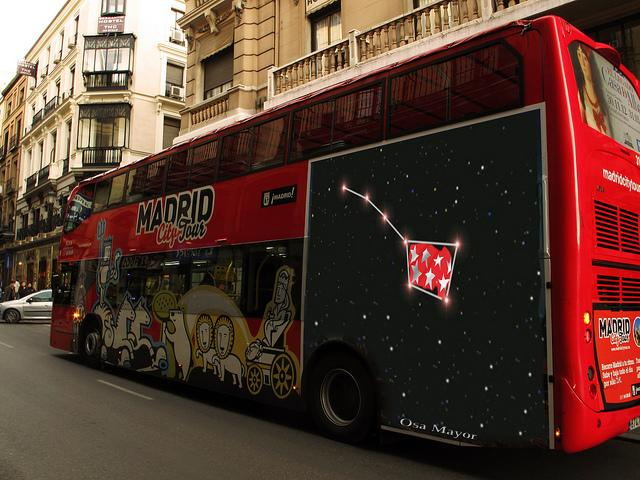What is this constellation often called in English?

Choices:
A) orion
B) big dipper
C) pisces
D) virgo big dipper 